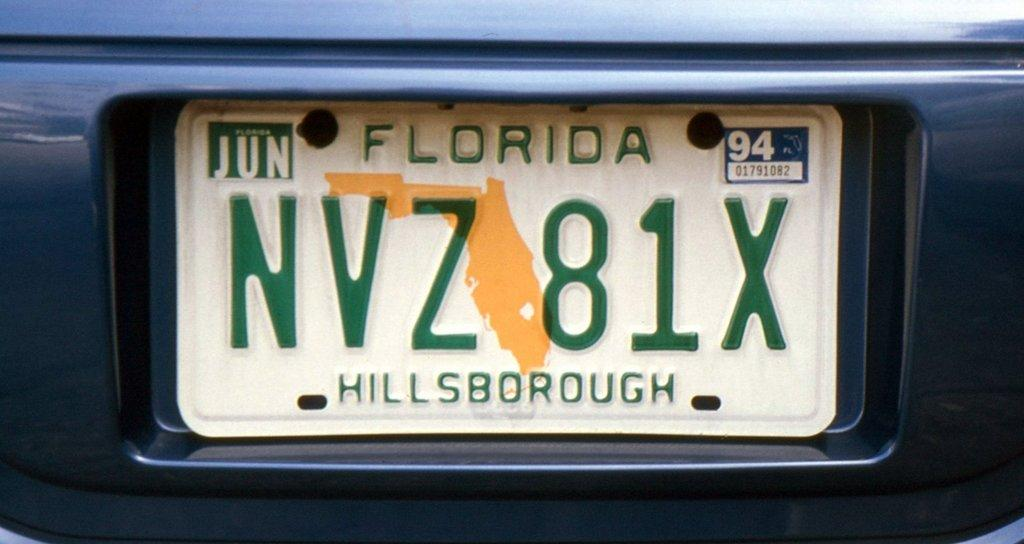<image>
Share a concise interpretation of the image provided. A Hillsborough County Florida tag that reads NVZ 81X. 